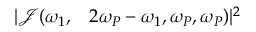Convert formula to latex. <formula><loc_0><loc_0><loc_500><loc_500>\begin{array} { r l } { | \mathcal { J } ( \omega _ { 1 } , } & 2 \omega _ { P } - \omega _ { 1 } , \omega _ { P } , \omega _ { P } ) | ^ { 2 } } \end{array}</formula> 